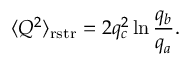<formula> <loc_0><loc_0><loc_500><loc_500>\langle Q ^ { 2 } \rangle _ { r s t r } = 2 q _ { c } ^ { 2 } \ln \frac { q _ { b } } { q _ { a } } .</formula> 